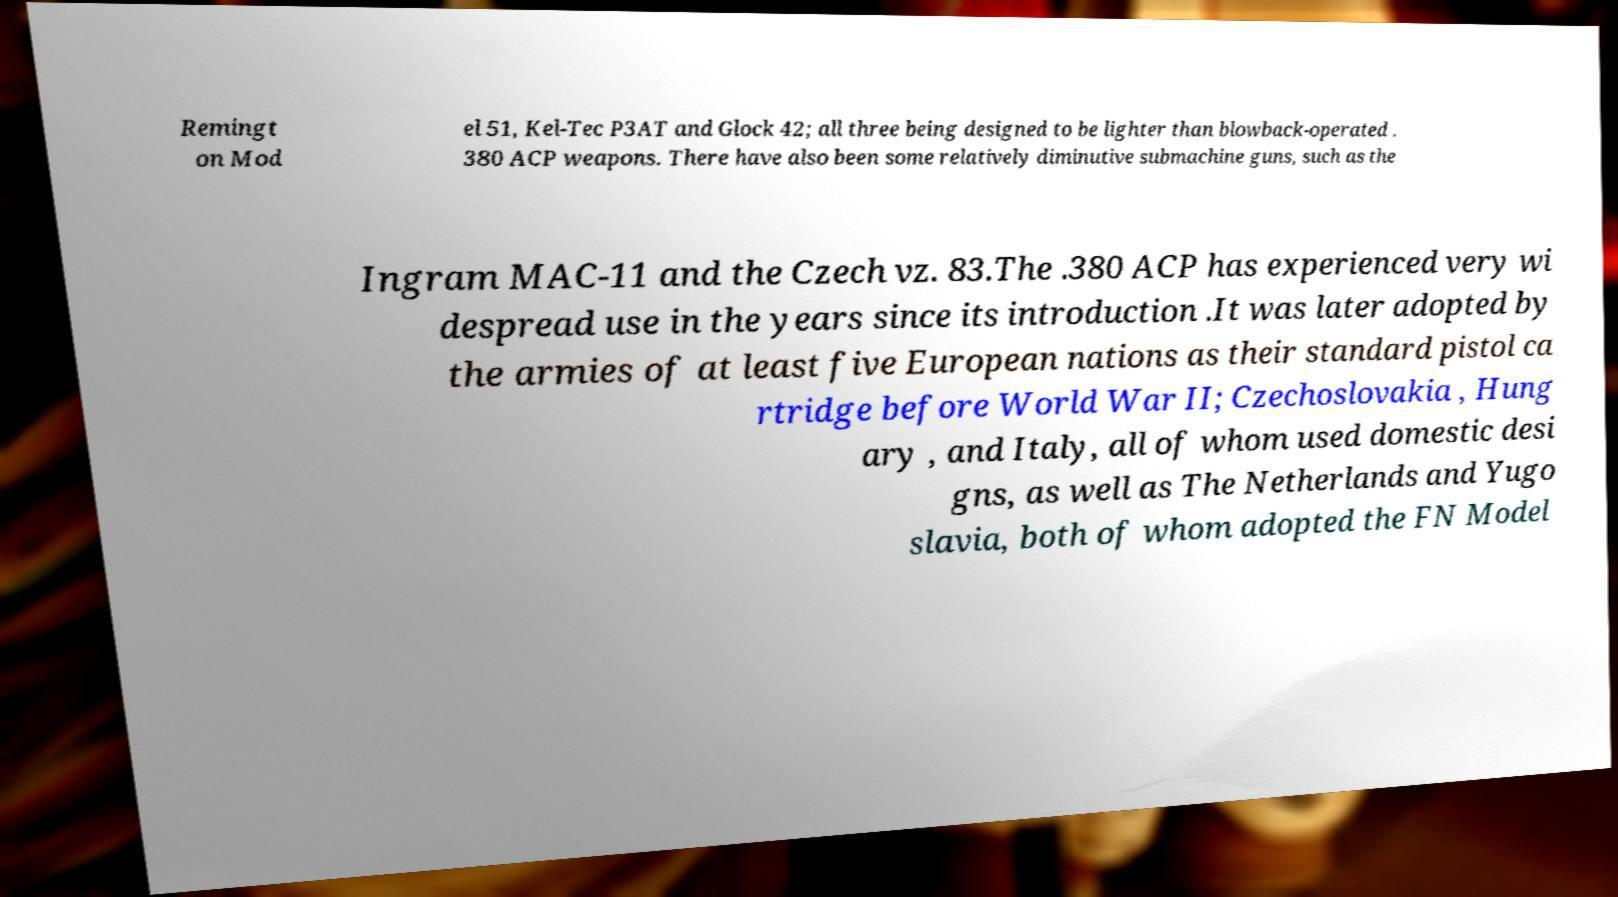Can you accurately transcribe the text from the provided image for me? Remingt on Mod el 51, Kel-Tec P3AT and Glock 42; all three being designed to be lighter than blowback-operated . 380 ACP weapons. There have also been some relatively diminutive submachine guns, such as the Ingram MAC-11 and the Czech vz. 83.The .380 ACP has experienced very wi despread use in the years since its introduction .It was later adopted by the armies of at least five European nations as their standard pistol ca rtridge before World War II; Czechoslovakia , Hung ary , and Italy, all of whom used domestic desi gns, as well as The Netherlands and Yugo slavia, both of whom adopted the FN Model 